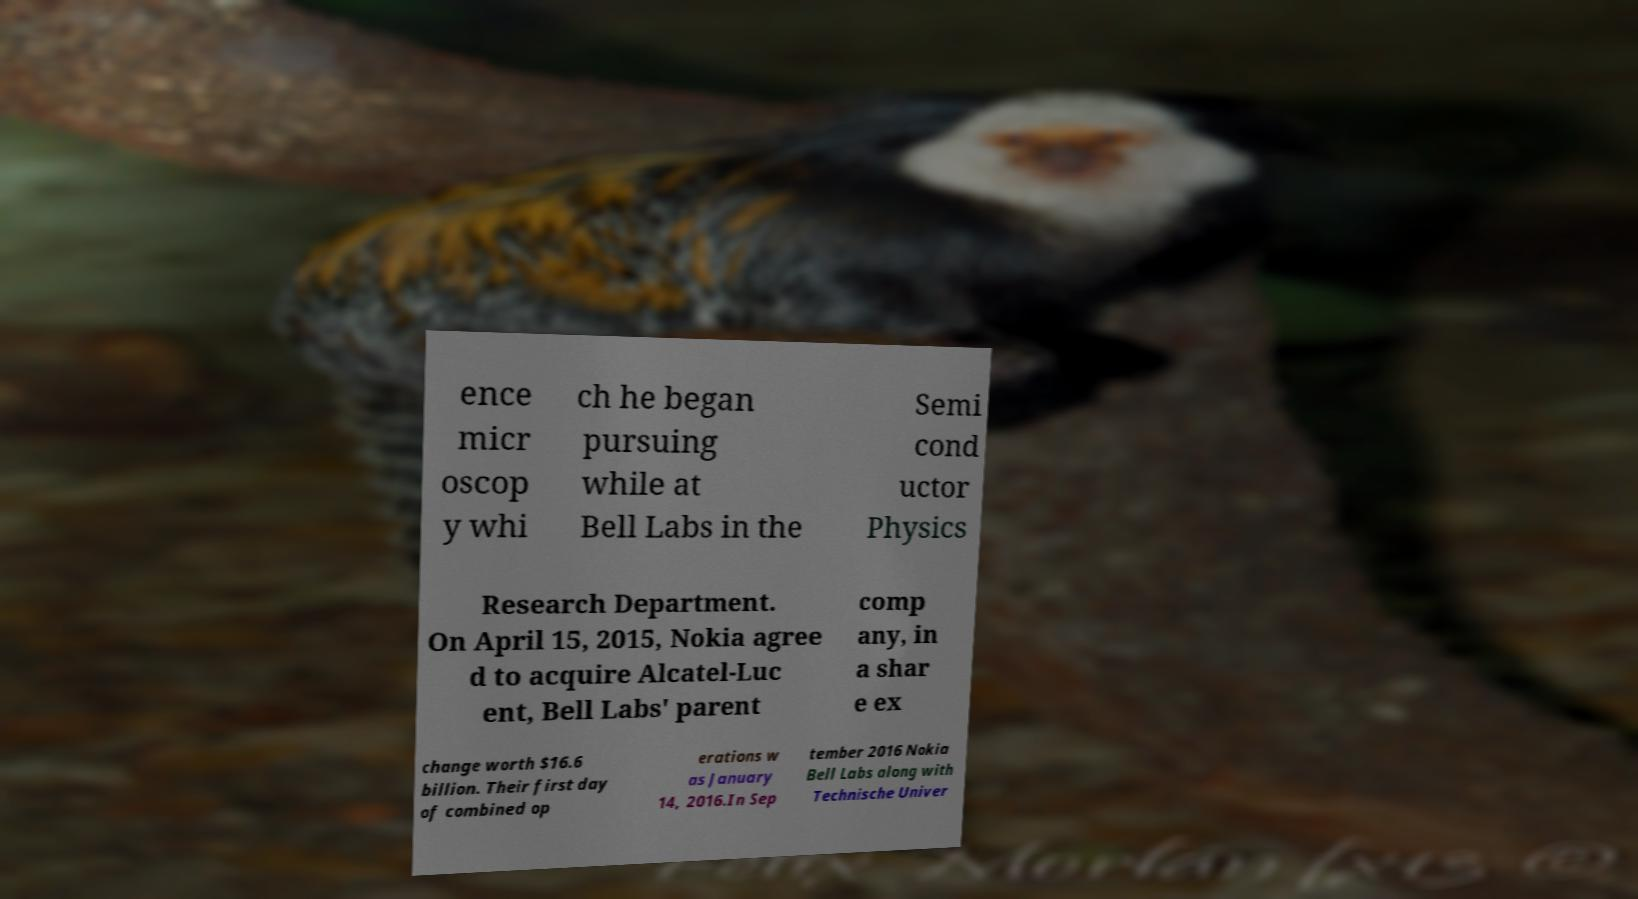Please identify and transcribe the text found in this image. ence micr oscop y whi ch he began pursuing while at Bell Labs in the Semi cond uctor Physics Research Department. On April 15, 2015, Nokia agree d to acquire Alcatel-Luc ent, Bell Labs' parent comp any, in a shar e ex change worth $16.6 billion. Their first day of combined op erations w as January 14, 2016.In Sep tember 2016 Nokia Bell Labs along with Technische Univer 